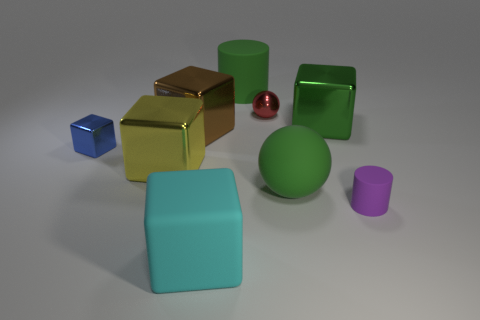Is the large yellow object the same shape as the big cyan object?
Offer a terse response. Yes. There is a small object that is left of the large green rubber thing behind the tiny metallic thing on the right side of the cyan block; what shape is it?
Provide a succinct answer. Cube. Does the big matte object that is behind the rubber sphere have the same shape as the small object that is in front of the yellow shiny thing?
Offer a very short reply. Yes. Is there a block made of the same material as the small red thing?
Keep it short and to the point. Yes. There is a block right of the green rubber thing that is behind the sphere in front of the blue shiny cube; what color is it?
Give a very brief answer. Green. Do the cylinder in front of the big brown cube and the cyan object to the left of the green matte cylinder have the same material?
Your response must be concise. Yes. What is the shape of the tiny metallic object that is on the left side of the yellow metal block?
Give a very brief answer. Cube. How many things are either large objects or cubes that are behind the small metallic block?
Provide a succinct answer. 6. Do the tiny cylinder and the small red thing have the same material?
Keep it short and to the point. No. Are there an equal number of red balls that are in front of the tiny cube and brown objects that are in front of the large cyan matte thing?
Keep it short and to the point. Yes. 